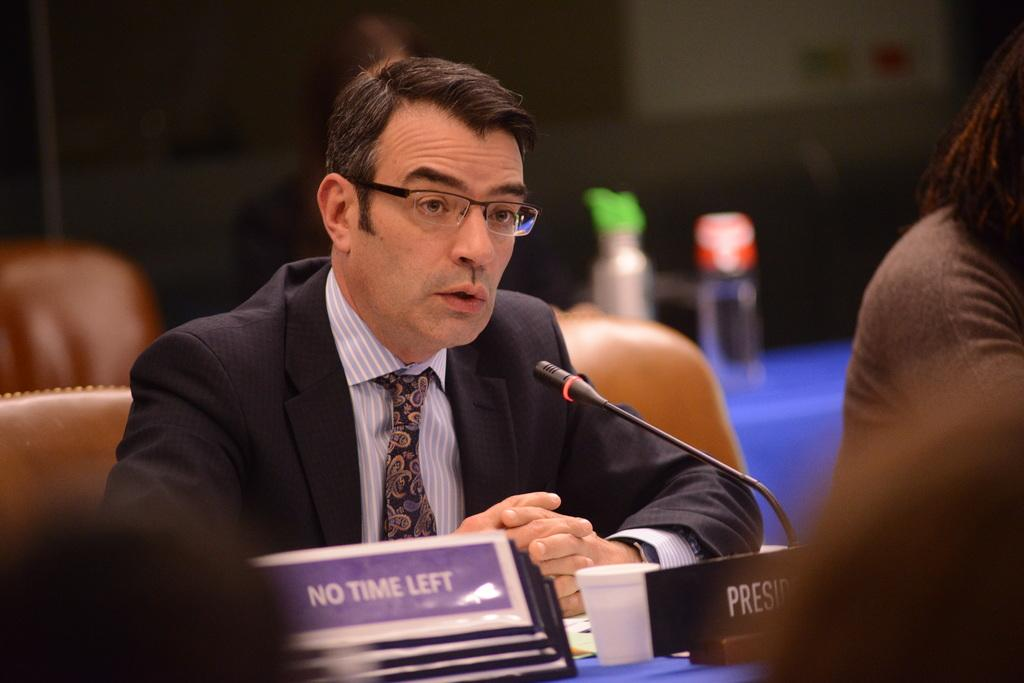What is the person in the image doing? The person is sitting on a chair in the image. What is in front of the person? There is a table in front of the person. What items can be seen on the table? There are plates, a cup, and a microphone (mike) on the table. How is the background of the image depicted? The background of the image is blurred. How many balloons are floating above the person's head in the image? There are no balloons visible in the image. What type of egg is being used as a prop in the image? There are no eggs present in the image. 